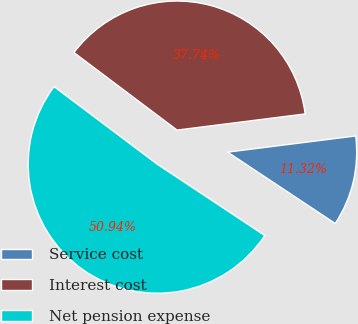<chart> <loc_0><loc_0><loc_500><loc_500><pie_chart><fcel>Service cost<fcel>Interest cost<fcel>Net pension expense<nl><fcel>11.32%<fcel>37.74%<fcel>50.94%<nl></chart> 